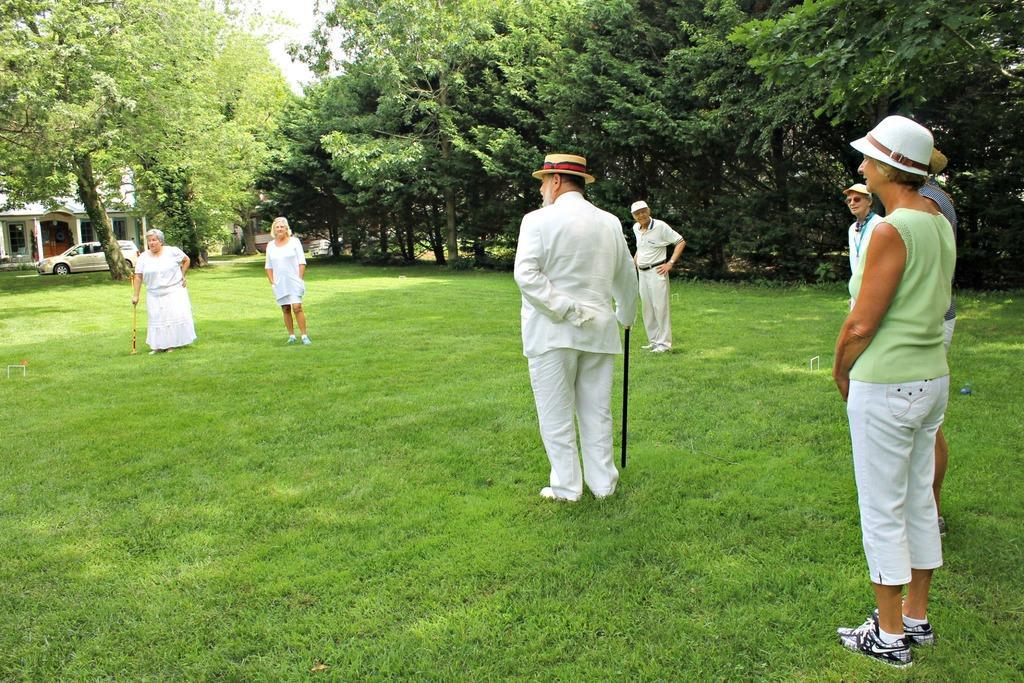Can you describe this image briefly? In this image, we can see some grass. There are people in the middle of the image wearing clothes. There are some trees at the top of the image. There is a building and car on the left side of the image. 